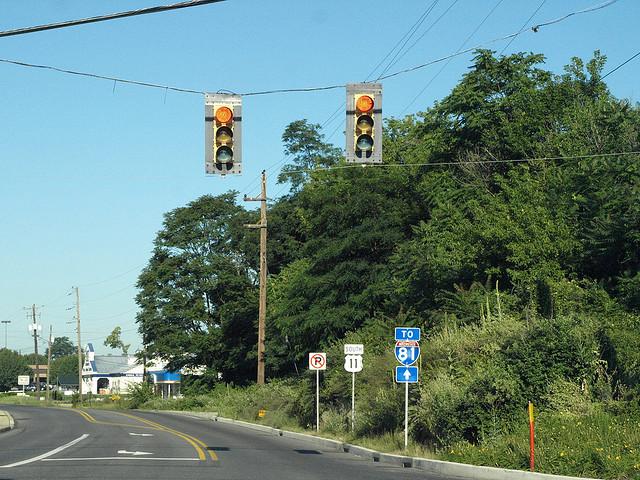How many power poles are visible?
Write a very short answer. 3. Is this a busy street?
Quick response, please. No. Can you park on the side of the road?
Concise answer only. No. 